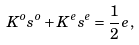Convert formula to latex. <formula><loc_0><loc_0><loc_500><loc_500>K ^ { o } s ^ { o } + K ^ { e } s ^ { e } = \frac { 1 } { 2 } e \, ,</formula> 